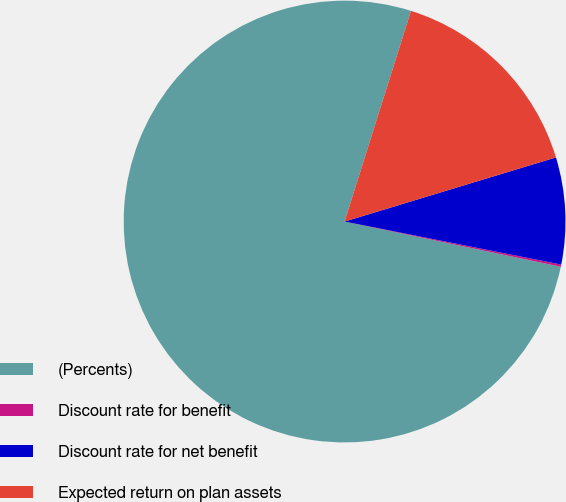Convert chart. <chart><loc_0><loc_0><loc_500><loc_500><pie_chart><fcel>(Percents)<fcel>Discount rate for benefit<fcel>Discount rate for net benefit<fcel>Expected return on plan assets<nl><fcel>76.58%<fcel>0.16%<fcel>7.81%<fcel>15.45%<nl></chart> 